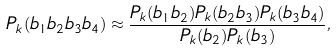Convert formula to latex. <formula><loc_0><loc_0><loc_500><loc_500>P _ { k } ( b _ { 1 } b _ { 2 } b _ { 3 } b _ { 4 } ) \approx \frac { P _ { k } ( b _ { 1 } b _ { 2 } ) P _ { k } ( b _ { 2 } b _ { 3 } ) P _ { k } ( b _ { 3 } b _ { 4 } ) } { P _ { k } ( b _ { 2 } ) P _ { k } ( b _ { 3 } ) } ,</formula> 